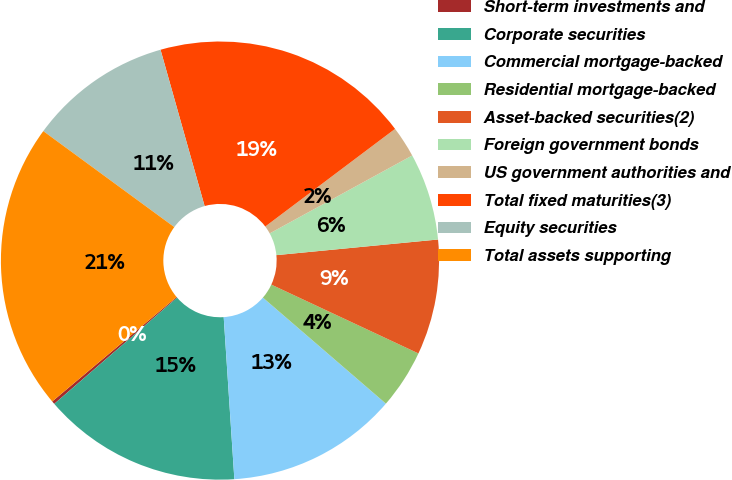Convert chart to OTSL. <chart><loc_0><loc_0><loc_500><loc_500><pie_chart><fcel>Short-term investments and<fcel>Corporate securities<fcel>Commercial mortgage-backed<fcel>Residential mortgage-backed<fcel>Asset-backed securities(2)<fcel>Foreign government bonds<fcel>US government authorities and<fcel>Total fixed maturities(3)<fcel>Equity securities<fcel>Total assets supporting<nl><fcel>0.23%<fcel>14.7%<fcel>12.63%<fcel>4.36%<fcel>8.5%<fcel>6.43%<fcel>2.3%<fcel>19.11%<fcel>10.56%<fcel>21.18%<nl></chart> 